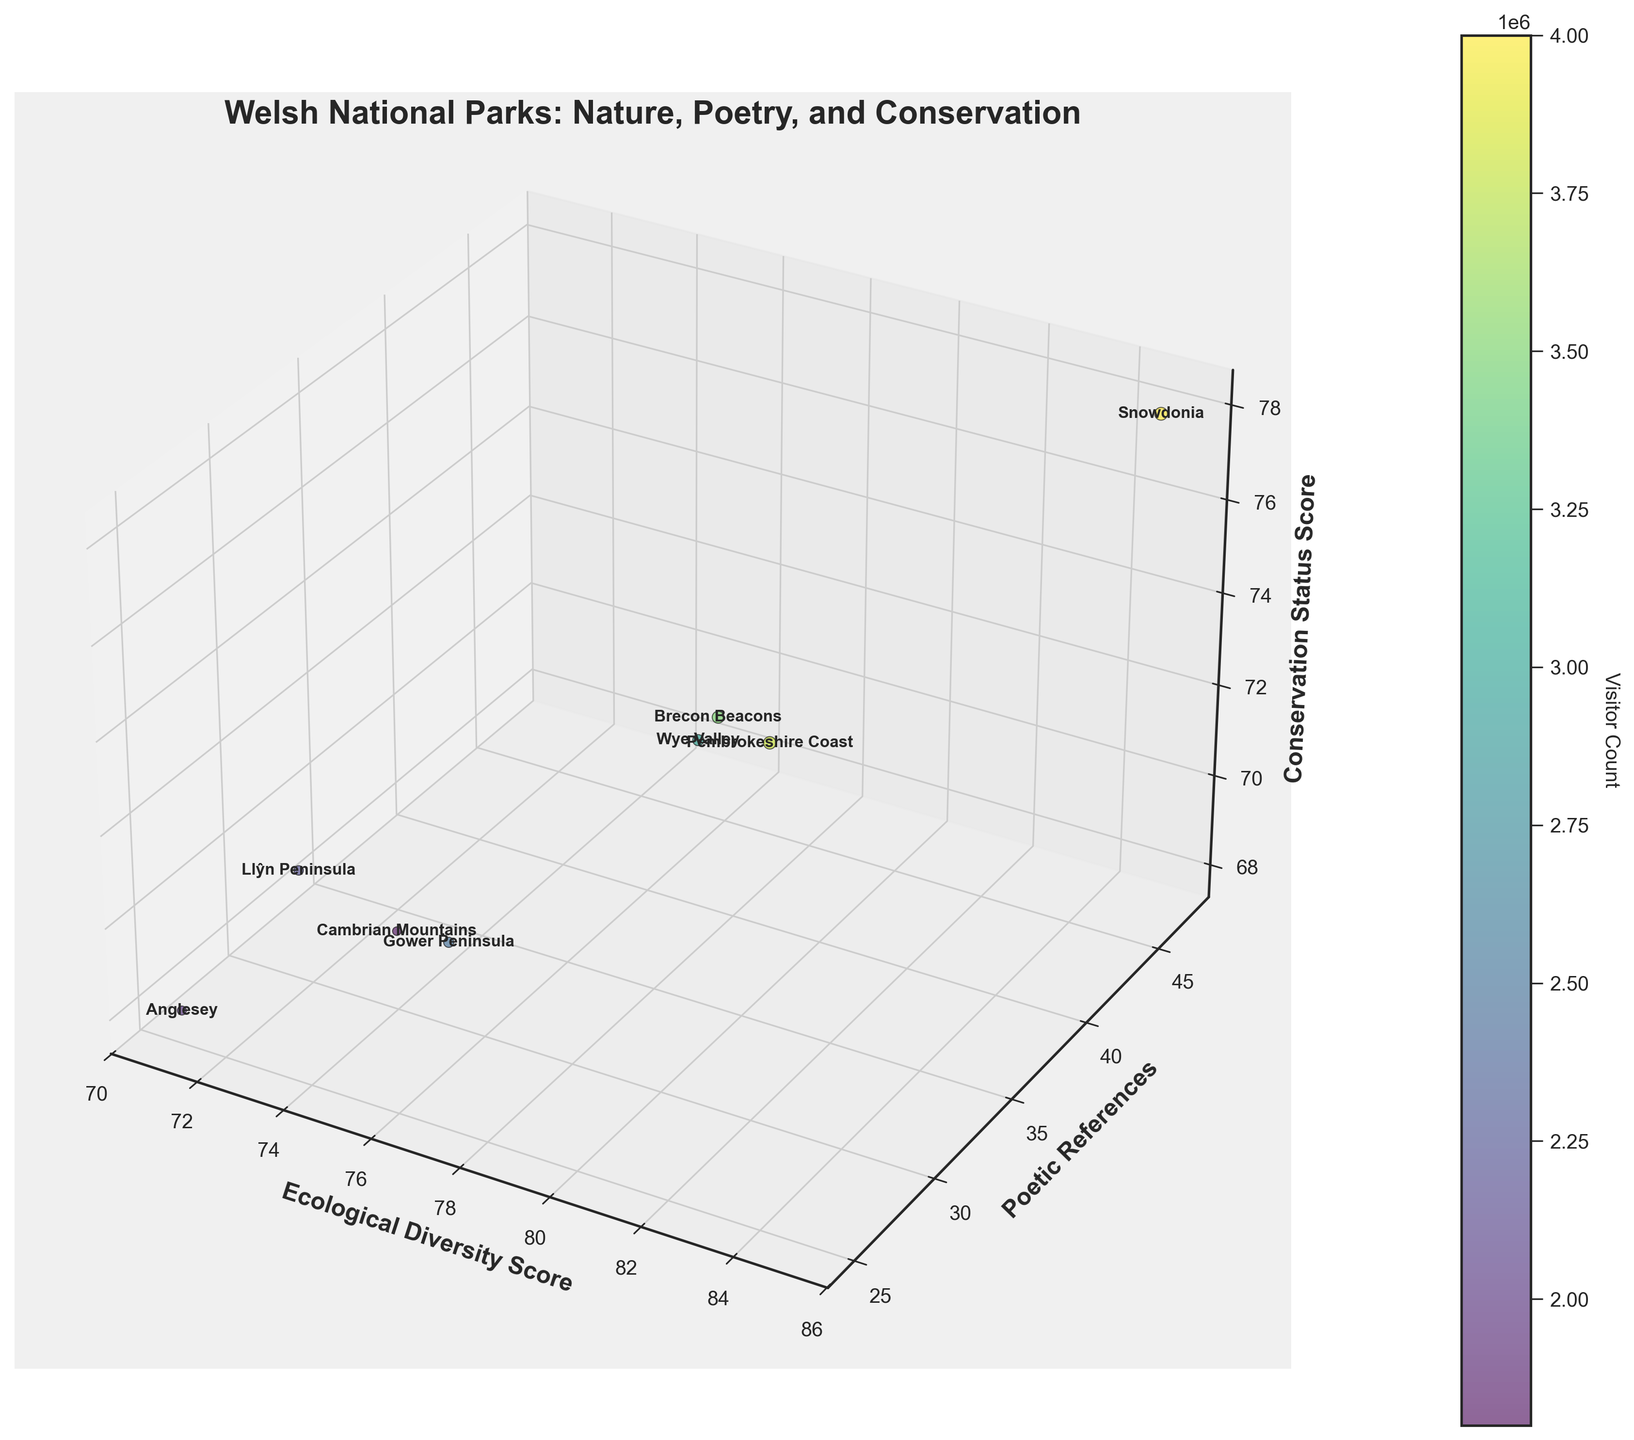Which Welsh national park has the highest ecological diversity score? Look for the bubble with the highest x-axis value which represents the ecological diversity score. Snowdonia has the highest score of 85.
Answer: Snowdonia How many parks have a poetic references score higher than 30? Count the number of bubbles where the y-axis values (poetic references) are greater than 30. There are 5 parks: Snowdonia, Brecon Beacons, Pembrokeshire Coast, Wye Valley, and Cambrian Mountains.
Answer: 5 Which park has the lowest conservation status score? Find the bubble with the lowest value on the z-axis, which represents the conservation status score. The lowest is Anglesey with a score of 68.
Answer: Anglesey What is the average visitor count for parks with an ecological diversity score above 80? Identify parks with ecological diversity scores greater than 80 (Snowdonia, Pembrokeshire Coast) and calculate the average visitor count: (4000000 + 3800000) / 2 equals 3,900,000.
Answer: 3,900,000 Which park stands out with both high ecological diversity and a high number of poetic references? Find the bubble situated high on both x and y axes. Snowdonia stands out with an ecological diversity score of 85 and poetic references score of 47.
Answer: Snowdonia Among parks with a visitor count above 3,000,000, which one has the lowest conservation status score? Identify parks with a visitor count above 3,000,000 (Snowdonia, Brecon Beacons, Pembrokeshire Coast, Wye Valley) and compare their conservation status scores. The lowest score is 72 from Brecon Beacons.
Answer: Brecon Beacons Which national park has the smallest bubble size? Bubble size represents visitor count. The smallest bubble corresponds to the park with the lowest visitor count, which is Cambrian Mountains with 1,800,000 visitors.
Answer: Cambrian Mountains What is the total number of poetic references for all parks combined? Sum the y-axis values representing poetic references for each park: 47 + 39 + 31 + 28 + 25 + 35 + 30 + 27 equals 262.
Answer: 262 Do parks with higher conservation status scores also tend to have higher ecological diversity scores? Compare the trends in the x-axis (ecological diversity) and z-axis (conservation status). Generally, parks with higher conservation status scores do have higher ecological diversity scores, with few exceptions.
Answer: Generally, yes Which parks have both ecological diversity and conservation status scores higher than 70? Identify bubbles with both x and z-axis values higher than 70. The parks are Snowdonia, Brecon Beacons, Pembrokeshire Coast, and Wye Valley.
Answer: Snowdonia, Brecon Beacons, Pembrokeshire Coast, Wye Valley 